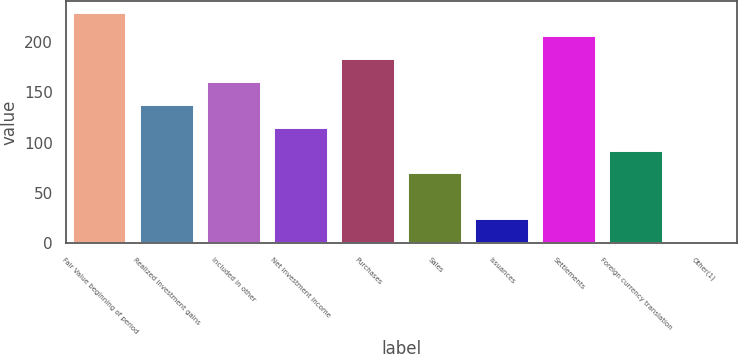Convert chart. <chart><loc_0><loc_0><loc_500><loc_500><bar_chart><fcel>Fair Value beginning of period<fcel>Realized investment gains<fcel>Included in other<fcel>Net investment income<fcel>Purchases<fcel>Sales<fcel>Issuances<fcel>Settlements<fcel>Foreign currency translation<fcel>Other(1)<nl><fcel>229.04<fcel>137.8<fcel>160.61<fcel>114.99<fcel>183.42<fcel>69.37<fcel>23.75<fcel>206.23<fcel>92.18<fcel>0.94<nl></chart> 